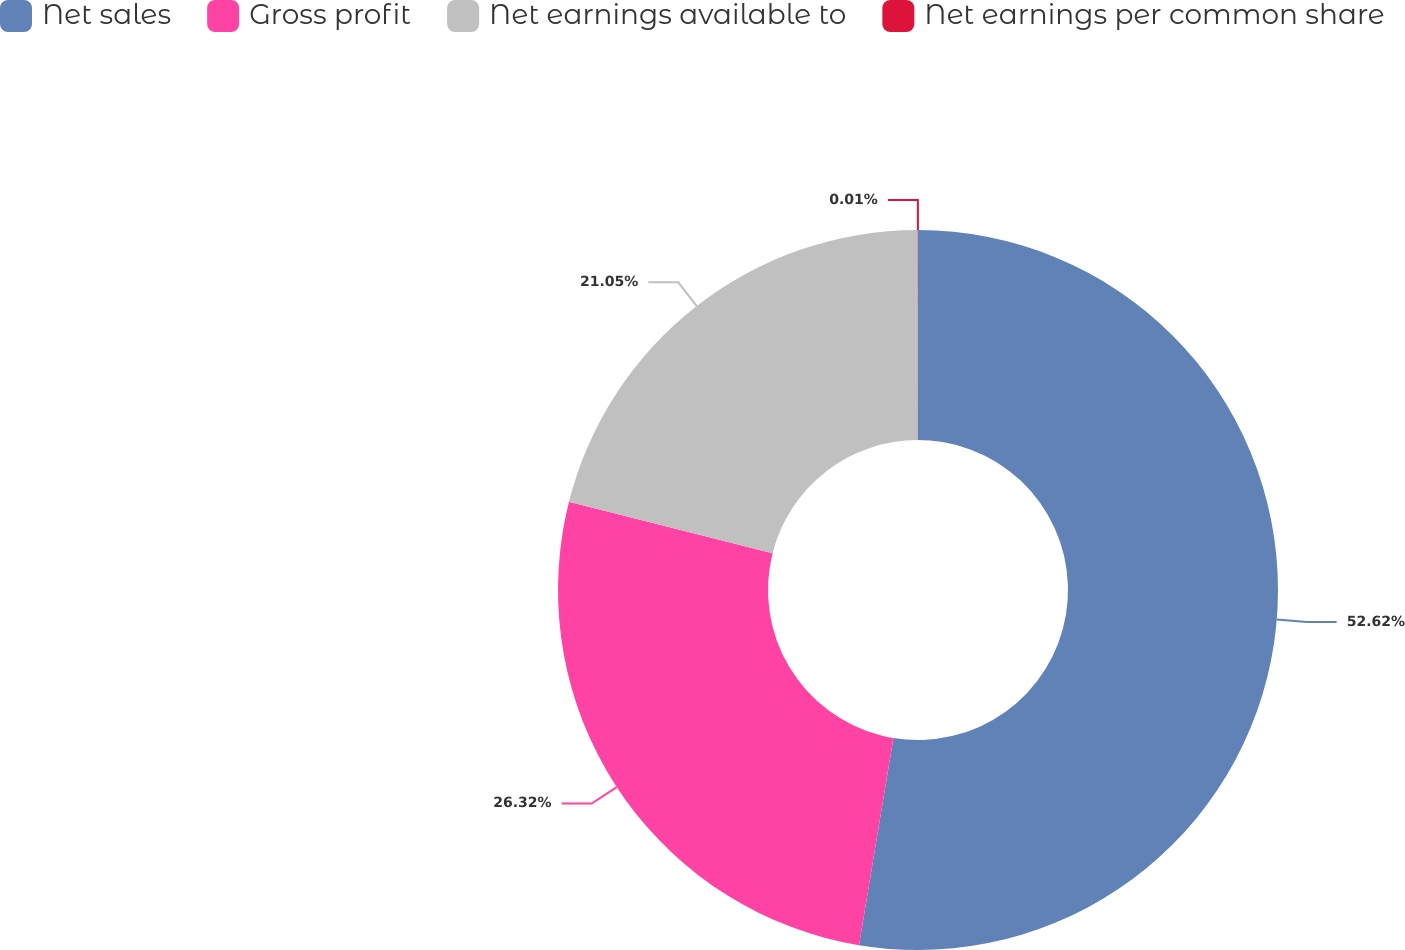Convert chart. <chart><loc_0><loc_0><loc_500><loc_500><pie_chart><fcel>Net sales<fcel>Gross profit<fcel>Net earnings available to<fcel>Net earnings per common share<nl><fcel>52.62%<fcel>26.32%<fcel>21.05%<fcel>0.01%<nl></chart> 